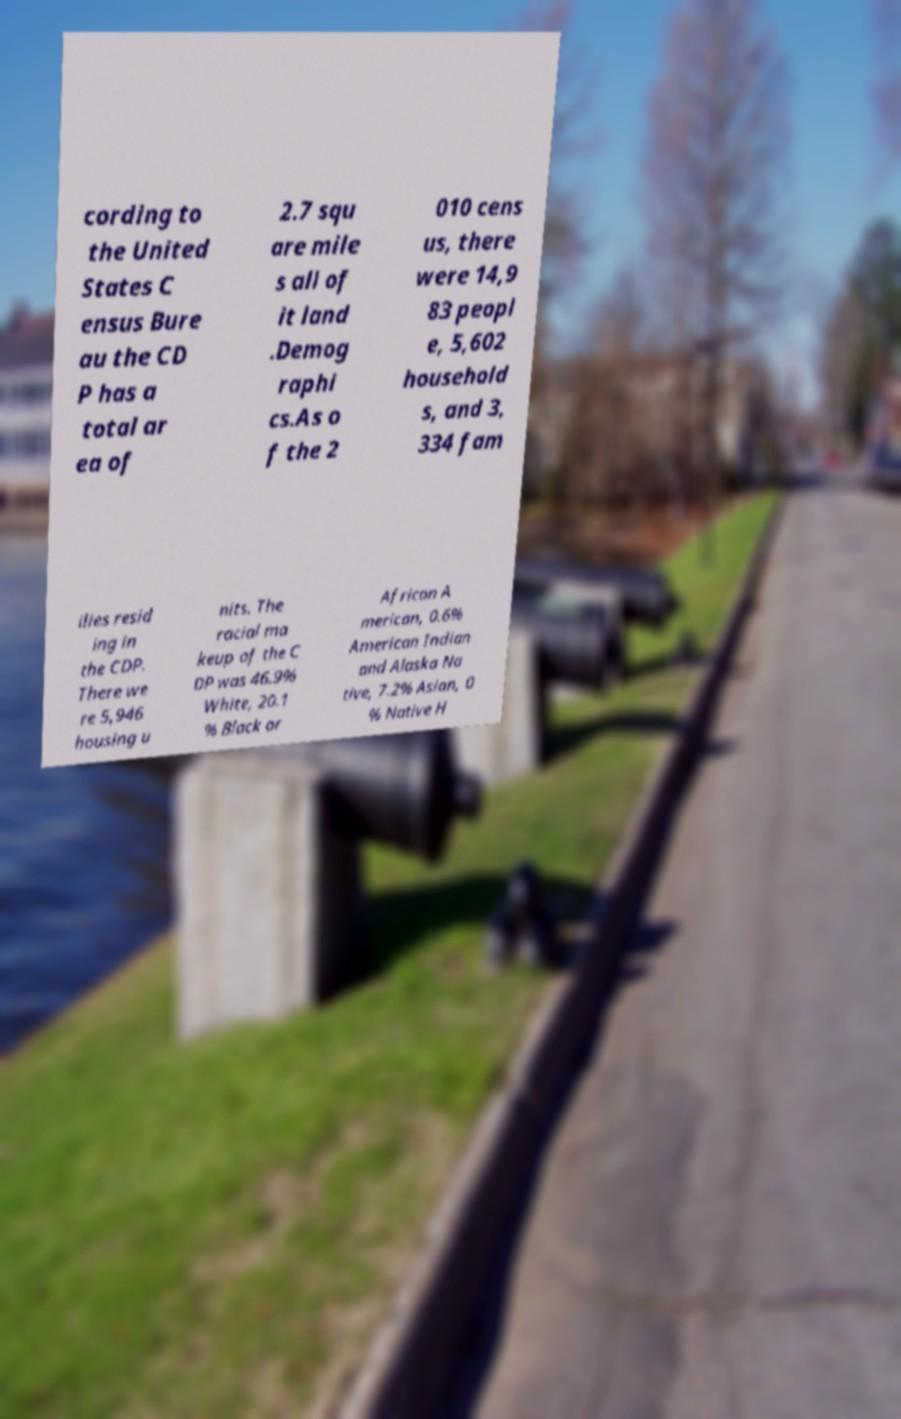Could you assist in decoding the text presented in this image and type it out clearly? cording to the United States C ensus Bure au the CD P has a total ar ea of 2.7 squ are mile s all of it land .Demog raphi cs.As o f the 2 010 cens us, there were 14,9 83 peopl e, 5,602 household s, and 3, 334 fam ilies resid ing in the CDP. There we re 5,946 housing u nits. The racial ma keup of the C DP was 46.9% White, 20.1 % Black or African A merican, 0.6% American Indian and Alaska Na tive, 7.2% Asian, 0 % Native H 